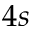Convert formula to latex. <formula><loc_0><loc_0><loc_500><loc_500>4 s</formula> 